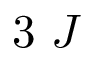<formula> <loc_0><loc_0><loc_500><loc_500>3 J</formula> 